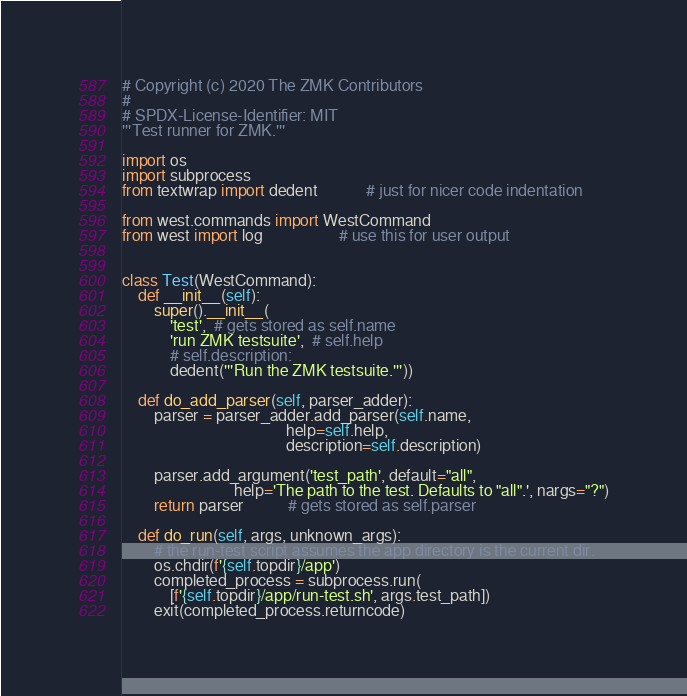Convert code to text. <code><loc_0><loc_0><loc_500><loc_500><_Python_># Copyright (c) 2020 The ZMK Contributors
#
# SPDX-License-Identifier: MIT
'''Test runner for ZMK.'''

import os
import subprocess
from textwrap import dedent            # just for nicer code indentation

from west.commands import WestCommand
from west import log                   # use this for user output


class Test(WestCommand):
    def __init__(self):
        super().__init__(
            'test',  # gets stored as self.name
            'run ZMK testsuite',  # self.help
            # self.description:
            dedent('''Run the ZMK testsuite.'''))

    def do_add_parser(self, parser_adder):
        parser = parser_adder.add_parser(self.name,
                                         help=self.help,
                                         description=self.description)

        parser.add_argument('test_path', default="all",
                            help='The path to the test. Defaults to "all".', nargs="?")
        return parser           # gets stored as self.parser

    def do_run(self, args, unknown_args):
        # the run-test script assumes the app directory is the current dir.
        os.chdir(f'{self.topdir}/app')
        completed_process = subprocess.run(
            [f'{self.topdir}/app/run-test.sh', args.test_path])
        exit(completed_process.returncode)
</code> 